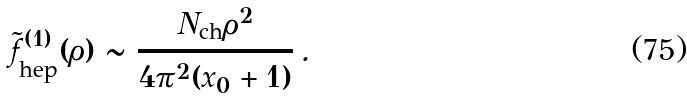<formula> <loc_0><loc_0><loc_500><loc_500>\tilde { f } ^ { ( 1 ) } _ { \text {hep} } ( \rho ) \sim \frac { N _ { \text {ch} } \rho ^ { 2 } } { 4 \pi ^ { 2 } ( x _ { 0 } + 1 ) } \, .</formula> 